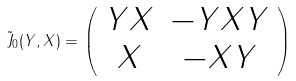<formula> <loc_0><loc_0><loc_500><loc_500>\tilde { J } _ { 0 } ( Y , X ) = \left ( \begin{array} { c c } Y X & - Y X Y \\ X & - X Y \end{array} \right )</formula> 